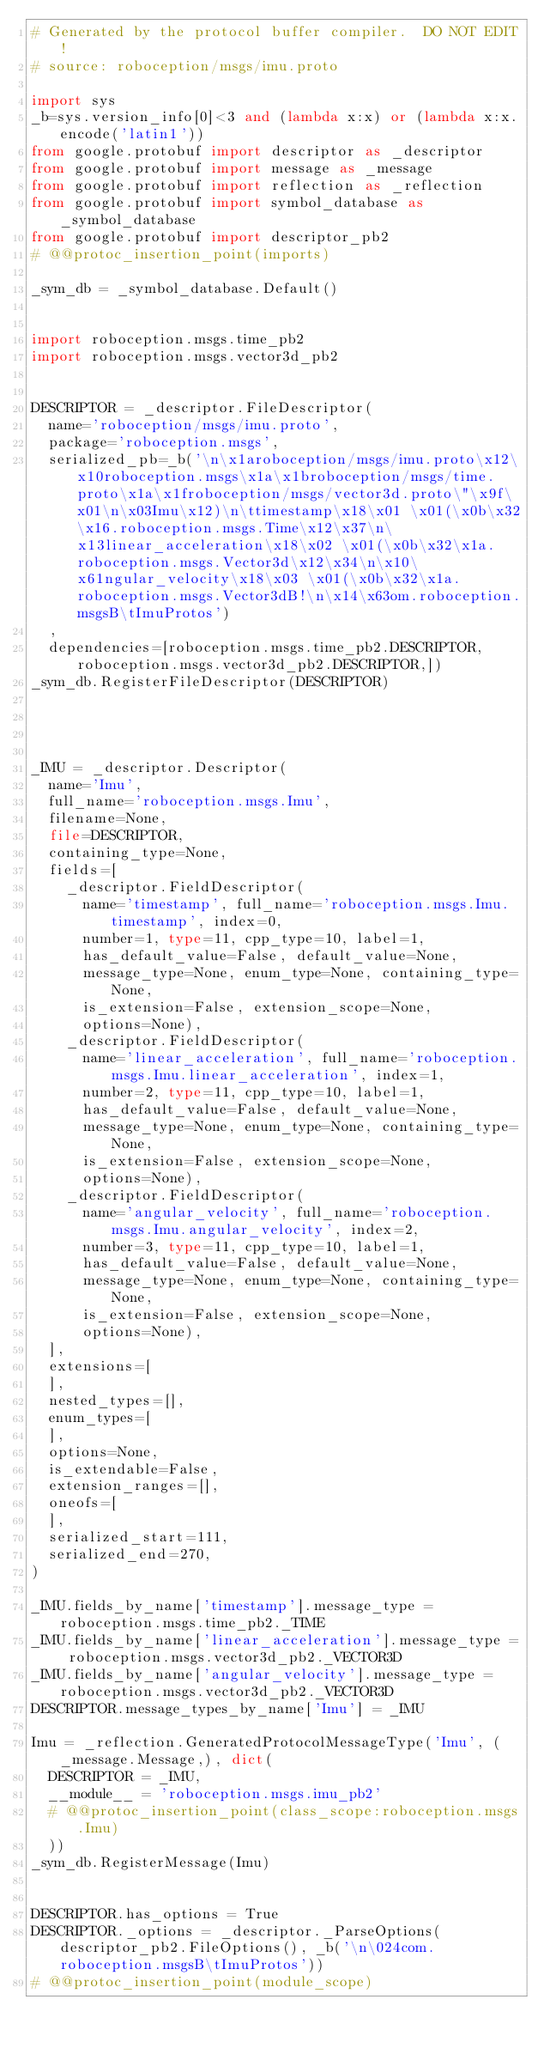<code> <loc_0><loc_0><loc_500><loc_500><_Python_># Generated by the protocol buffer compiler.  DO NOT EDIT!
# source: roboception/msgs/imu.proto

import sys
_b=sys.version_info[0]<3 and (lambda x:x) or (lambda x:x.encode('latin1'))
from google.protobuf import descriptor as _descriptor
from google.protobuf import message as _message
from google.protobuf import reflection as _reflection
from google.protobuf import symbol_database as _symbol_database
from google.protobuf import descriptor_pb2
# @@protoc_insertion_point(imports)

_sym_db = _symbol_database.Default()


import roboception.msgs.time_pb2
import roboception.msgs.vector3d_pb2


DESCRIPTOR = _descriptor.FileDescriptor(
  name='roboception/msgs/imu.proto',
  package='roboception.msgs',
  serialized_pb=_b('\n\x1aroboception/msgs/imu.proto\x12\x10roboception.msgs\x1a\x1broboception/msgs/time.proto\x1a\x1froboception/msgs/vector3d.proto\"\x9f\x01\n\x03Imu\x12)\n\ttimestamp\x18\x01 \x01(\x0b\x32\x16.roboception.msgs.Time\x12\x37\n\x13linear_acceleration\x18\x02 \x01(\x0b\x32\x1a.roboception.msgs.Vector3d\x12\x34\n\x10\x61ngular_velocity\x18\x03 \x01(\x0b\x32\x1a.roboception.msgs.Vector3dB!\n\x14\x63om.roboception.msgsB\tImuProtos')
  ,
  dependencies=[roboception.msgs.time_pb2.DESCRIPTOR,roboception.msgs.vector3d_pb2.DESCRIPTOR,])
_sym_db.RegisterFileDescriptor(DESCRIPTOR)




_IMU = _descriptor.Descriptor(
  name='Imu',
  full_name='roboception.msgs.Imu',
  filename=None,
  file=DESCRIPTOR,
  containing_type=None,
  fields=[
    _descriptor.FieldDescriptor(
      name='timestamp', full_name='roboception.msgs.Imu.timestamp', index=0,
      number=1, type=11, cpp_type=10, label=1,
      has_default_value=False, default_value=None,
      message_type=None, enum_type=None, containing_type=None,
      is_extension=False, extension_scope=None,
      options=None),
    _descriptor.FieldDescriptor(
      name='linear_acceleration', full_name='roboception.msgs.Imu.linear_acceleration', index=1,
      number=2, type=11, cpp_type=10, label=1,
      has_default_value=False, default_value=None,
      message_type=None, enum_type=None, containing_type=None,
      is_extension=False, extension_scope=None,
      options=None),
    _descriptor.FieldDescriptor(
      name='angular_velocity', full_name='roboception.msgs.Imu.angular_velocity', index=2,
      number=3, type=11, cpp_type=10, label=1,
      has_default_value=False, default_value=None,
      message_type=None, enum_type=None, containing_type=None,
      is_extension=False, extension_scope=None,
      options=None),
  ],
  extensions=[
  ],
  nested_types=[],
  enum_types=[
  ],
  options=None,
  is_extendable=False,
  extension_ranges=[],
  oneofs=[
  ],
  serialized_start=111,
  serialized_end=270,
)

_IMU.fields_by_name['timestamp'].message_type = roboception.msgs.time_pb2._TIME
_IMU.fields_by_name['linear_acceleration'].message_type = roboception.msgs.vector3d_pb2._VECTOR3D
_IMU.fields_by_name['angular_velocity'].message_type = roboception.msgs.vector3d_pb2._VECTOR3D
DESCRIPTOR.message_types_by_name['Imu'] = _IMU

Imu = _reflection.GeneratedProtocolMessageType('Imu', (_message.Message,), dict(
  DESCRIPTOR = _IMU,
  __module__ = 'roboception.msgs.imu_pb2'
  # @@protoc_insertion_point(class_scope:roboception.msgs.Imu)
  ))
_sym_db.RegisterMessage(Imu)


DESCRIPTOR.has_options = True
DESCRIPTOR._options = _descriptor._ParseOptions(descriptor_pb2.FileOptions(), _b('\n\024com.roboception.msgsB\tImuProtos'))
# @@protoc_insertion_point(module_scope)
</code> 